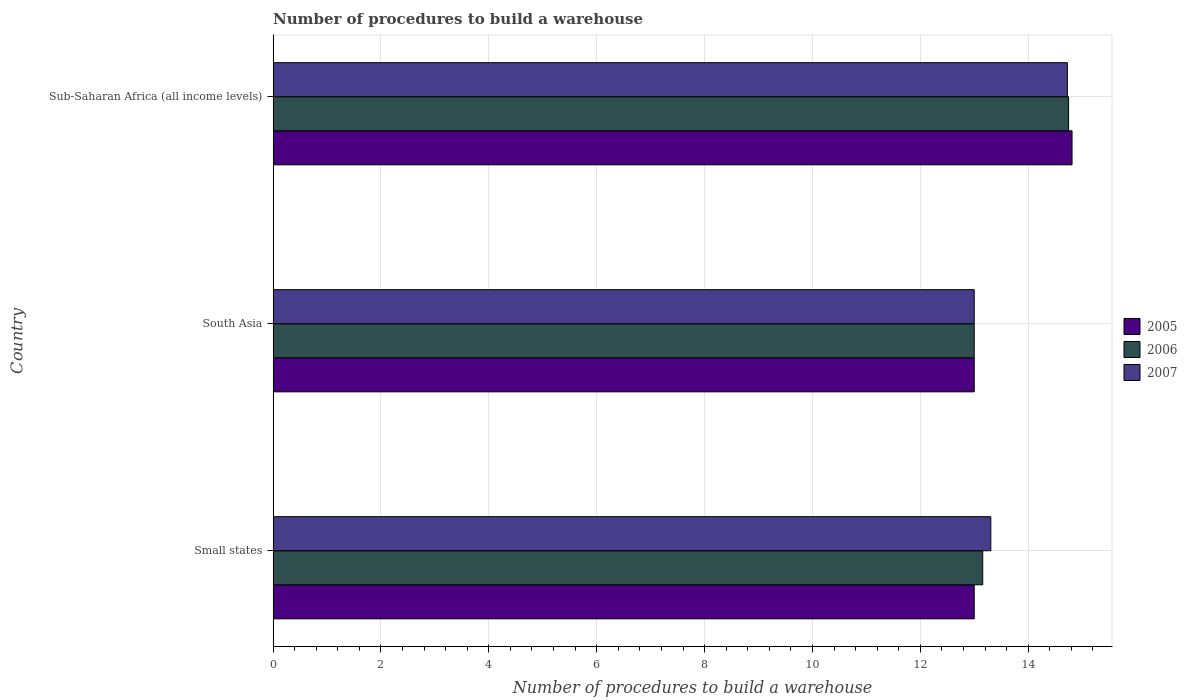How many bars are there on the 1st tick from the bottom?
Give a very brief answer. 3. What is the label of the 3rd group of bars from the top?
Your answer should be compact. Small states. What is the number of procedures to build a warehouse in in 2006 in Small states?
Make the answer very short. 13.16. Across all countries, what is the maximum number of procedures to build a warehouse in in 2007?
Offer a very short reply. 14.73. Across all countries, what is the minimum number of procedures to build a warehouse in in 2005?
Ensure brevity in your answer.  13. In which country was the number of procedures to build a warehouse in in 2005 maximum?
Provide a succinct answer. Sub-Saharan Africa (all income levels). What is the total number of procedures to build a warehouse in in 2005 in the graph?
Make the answer very short. 40.81. What is the difference between the number of procedures to build a warehouse in in 2006 in South Asia and that in Sub-Saharan Africa (all income levels)?
Offer a very short reply. -1.75. What is the difference between the number of procedures to build a warehouse in in 2005 in South Asia and the number of procedures to build a warehouse in in 2006 in Sub-Saharan Africa (all income levels)?
Provide a succinct answer. -1.75. What is the average number of procedures to build a warehouse in in 2007 per country?
Offer a very short reply. 13.68. What is the ratio of the number of procedures to build a warehouse in in 2005 in Small states to that in Sub-Saharan Africa (all income levels)?
Offer a terse response. 0.88. Is the difference between the number of procedures to build a warehouse in in 2005 in Small states and South Asia greater than the difference between the number of procedures to build a warehouse in in 2007 in Small states and South Asia?
Keep it short and to the point. No. What is the difference between the highest and the second highest number of procedures to build a warehouse in in 2007?
Make the answer very short. 1.42. What is the difference between the highest and the lowest number of procedures to build a warehouse in in 2005?
Provide a succinct answer. 1.81. What does the 3rd bar from the bottom in Small states represents?
Keep it short and to the point. 2007. How many bars are there?
Provide a succinct answer. 9. Are all the bars in the graph horizontal?
Your answer should be compact. Yes. How many countries are there in the graph?
Your answer should be compact. 3. Where does the legend appear in the graph?
Make the answer very short. Center right. How many legend labels are there?
Offer a very short reply. 3. What is the title of the graph?
Ensure brevity in your answer.  Number of procedures to build a warehouse. Does "1982" appear as one of the legend labels in the graph?
Keep it short and to the point. No. What is the label or title of the X-axis?
Provide a succinct answer. Number of procedures to build a warehouse. What is the label or title of the Y-axis?
Ensure brevity in your answer.  Country. What is the Number of procedures to build a warehouse in 2005 in Small states?
Make the answer very short. 13. What is the Number of procedures to build a warehouse in 2006 in Small states?
Give a very brief answer. 13.16. What is the Number of procedures to build a warehouse of 2007 in Small states?
Offer a very short reply. 13.31. What is the Number of procedures to build a warehouse in 2005 in South Asia?
Offer a very short reply. 13. What is the Number of procedures to build a warehouse of 2006 in South Asia?
Provide a short and direct response. 13. What is the Number of procedures to build a warehouse of 2005 in Sub-Saharan Africa (all income levels)?
Offer a terse response. 14.81. What is the Number of procedures to build a warehouse in 2006 in Sub-Saharan Africa (all income levels)?
Ensure brevity in your answer.  14.75. What is the Number of procedures to build a warehouse of 2007 in Sub-Saharan Africa (all income levels)?
Give a very brief answer. 14.73. Across all countries, what is the maximum Number of procedures to build a warehouse in 2005?
Offer a terse response. 14.81. Across all countries, what is the maximum Number of procedures to build a warehouse of 2006?
Your answer should be very brief. 14.75. Across all countries, what is the maximum Number of procedures to build a warehouse in 2007?
Offer a very short reply. 14.73. Across all countries, what is the minimum Number of procedures to build a warehouse of 2005?
Provide a succinct answer. 13. Across all countries, what is the minimum Number of procedures to build a warehouse in 2006?
Offer a terse response. 13. Across all countries, what is the minimum Number of procedures to build a warehouse in 2007?
Keep it short and to the point. 13. What is the total Number of procedures to build a warehouse in 2005 in the graph?
Your answer should be compact. 40.81. What is the total Number of procedures to build a warehouse in 2006 in the graph?
Your answer should be compact. 40.91. What is the total Number of procedures to build a warehouse in 2007 in the graph?
Make the answer very short. 41.03. What is the difference between the Number of procedures to build a warehouse of 2005 in Small states and that in South Asia?
Your answer should be very brief. 0. What is the difference between the Number of procedures to build a warehouse of 2006 in Small states and that in South Asia?
Offer a very short reply. 0.16. What is the difference between the Number of procedures to build a warehouse of 2007 in Small states and that in South Asia?
Give a very brief answer. 0.31. What is the difference between the Number of procedures to build a warehouse in 2005 in Small states and that in Sub-Saharan Africa (all income levels)?
Your answer should be compact. -1.81. What is the difference between the Number of procedures to build a warehouse in 2006 in Small states and that in Sub-Saharan Africa (all income levels)?
Keep it short and to the point. -1.59. What is the difference between the Number of procedures to build a warehouse of 2007 in Small states and that in Sub-Saharan Africa (all income levels)?
Offer a very short reply. -1.42. What is the difference between the Number of procedures to build a warehouse of 2005 in South Asia and that in Sub-Saharan Africa (all income levels)?
Your answer should be very brief. -1.81. What is the difference between the Number of procedures to build a warehouse of 2006 in South Asia and that in Sub-Saharan Africa (all income levels)?
Your response must be concise. -1.75. What is the difference between the Number of procedures to build a warehouse in 2007 in South Asia and that in Sub-Saharan Africa (all income levels)?
Provide a succinct answer. -1.73. What is the difference between the Number of procedures to build a warehouse in 2005 in Small states and the Number of procedures to build a warehouse in 2006 in South Asia?
Make the answer very short. 0. What is the difference between the Number of procedures to build a warehouse in 2005 in Small states and the Number of procedures to build a warehouse in 2007 in South Asia?
Offer a terse response. 0. What is the difference between the Number of procedures to build a warehouse of 2006 in Small states and the Number of procedures to build a warehouse of 2007 in South Asia?
Your answer should be compact. 0.16. What is the difference between the Number of procedures to build a warehouse of 2005 in Small states and the Number of procedures to build a warehouse of 2006 in Sub-Saharan Africa (all income levels)?
Keep it short and to the point. -1.75. What is the difference between the Number of procedures to build a warehouse of 2005 in Small states and the Number of procedures to build a warehouse of 2007 in Sub-Saharan Africa (all income levels)?
Offer a terse response. -1.73. What is the difference between the Number of procedures to build a warehouse in 2006 in Small states and the Number of procedures to build a warehouse in 2007 in Sub-Saharan Africa (all income levels)?
Your answer should be compact. -1.57. What is the difference between the Number of procedures to build a warehouse of 2005 in South Asia and the Number of procedures to build a warehouse of 2006 in Sub-Saharan Africa (all income levels)?
Offer a very short reply. -1.75. What is the difference between the Number of procedures to build a warehouse of 2005 in South Asia and the Number of procedures to build a warehouse of 2007 in Sub-Saharan Africa (all income levels)?
Provide a succinct answer. -1.73. What is the difference between the Number of procedures to build a warehouse in 2006 in South Asia and the Number of procedures to build a warehouse in 2007 in Sub-Saharan Africa (all income levels)?
Provide a succinct answer. -1.73. What is the average Number of procedures to build a warehouse of 2005 per country?
Your answer should be compact. 13.6. What is the average Number of procedures to build a warehouse in 2006 per country?
Your response must be concise. 13.64. What is the average Number of procedures to build a warehouse of 2007 per country?
Offer a very short reply. 13.68. What is the difference between the Number of procedures to build a warehouse of 2005 and Number of procedures to build a warehouse of 2006 in Small states?
Your answer should be compact. -0.16. What is the difference between the Number of procedures to build a warehouse of 2005 and Number of procedures to build a warehouse of 2007 in Small states?
Offer a very short reply. -0.31. What is the difference between the Number of procedures to build a warehouse of 2006 and Number of procedures to build a warehouse of 2007 in Small states?
Offer a terse response. -0.15. What is the difference between the Number of procedures to build a warehouse in 2005 and Number of procedures to build a warehouse in 2006 in Sub-Saharan Africa (all income levels)?
Make the answer very short. 0.06. What is the difference between the Number of procedures to build a warehouse of 2005 and Number of procedures to build a warehouse of 2007 in Sub-Saharan Africa (all income levels)?
Your answer should be compact. 0.09. What is the difference between the Number of procedures to build a warehouse of 2006 and Number of procedures to build a warehouse of 2007 in Sub-Saharan Africa (all income levels)?
Make the answer very short. 0.02. What is the ratio of the Number of procedures to build a warehouse in 2006 in Small states to that in South Asia?
Your answer should be compact. 1.01. What is the ratio of the Number of procedures to build a warehouse in 2007 in Small states to that in South Asia?
Ensure brevity in your answer.  1.02. What is the ratio of the Number of procedures to build a warehouse in 2005 in Small states to that in Sub-Saharan Africa (all income levels)?
Offer a terse response. 0.88. What is the ratio of the Number of procedures to build a warehouse of 2006 in Small states to that in Sub-Saharan Africa (all income levels)?
Provide a short and direct response. 0.89. What is the ratio of the Number of procedures to build a warehouse in 2007 in Small states to that in Sub-Saharan Africa (all income levels)?
Your answer should be very brief. 0.9. What is the ratio of the Number of procedures to build a warehouse in 2005 in South Asia to that in Sub-Saharan Africa (all income levels)?
Your answer should be very brief. 0.88. What is the ratio of the Number of procedures to build a warehouse of 2006 in South Asia to that in Sub-Saharan Africa (all income levels)?
Your response must be concise. 0.88. What is the ratio of the Number of procedures to build a warehouse in 2007 in South Asia to that in Sub-Saharan Africa (all income levels)?
Your answer should be compact. 0.88. What is the difference between the highest and the second highest Number of procedures to build a warehouse of 2005?
Provide a succinct answer. 1.81. What is the difference between the highest and the second highest Number of procedures to build a warehouse of 2006?
Your answer should be very brief. 1.59. What is the difference between the highest and the second highest Number of procedures to build a warehouse in 2007?
Give a very brief answer. 1.42. What is the difference between the highest and the lowest Number of procedures to build a warehouse in 2005?
Your answer should be very brief. 1.81. What is the difference between the highest and the lowest Number of procedures to build a warehouse of 2006?
Offer a very short reply. 1.75. What is the difference between the highest and the lowest Number of procedures to build a warehouse in 2007?
Your response must be concise. 1.73. 